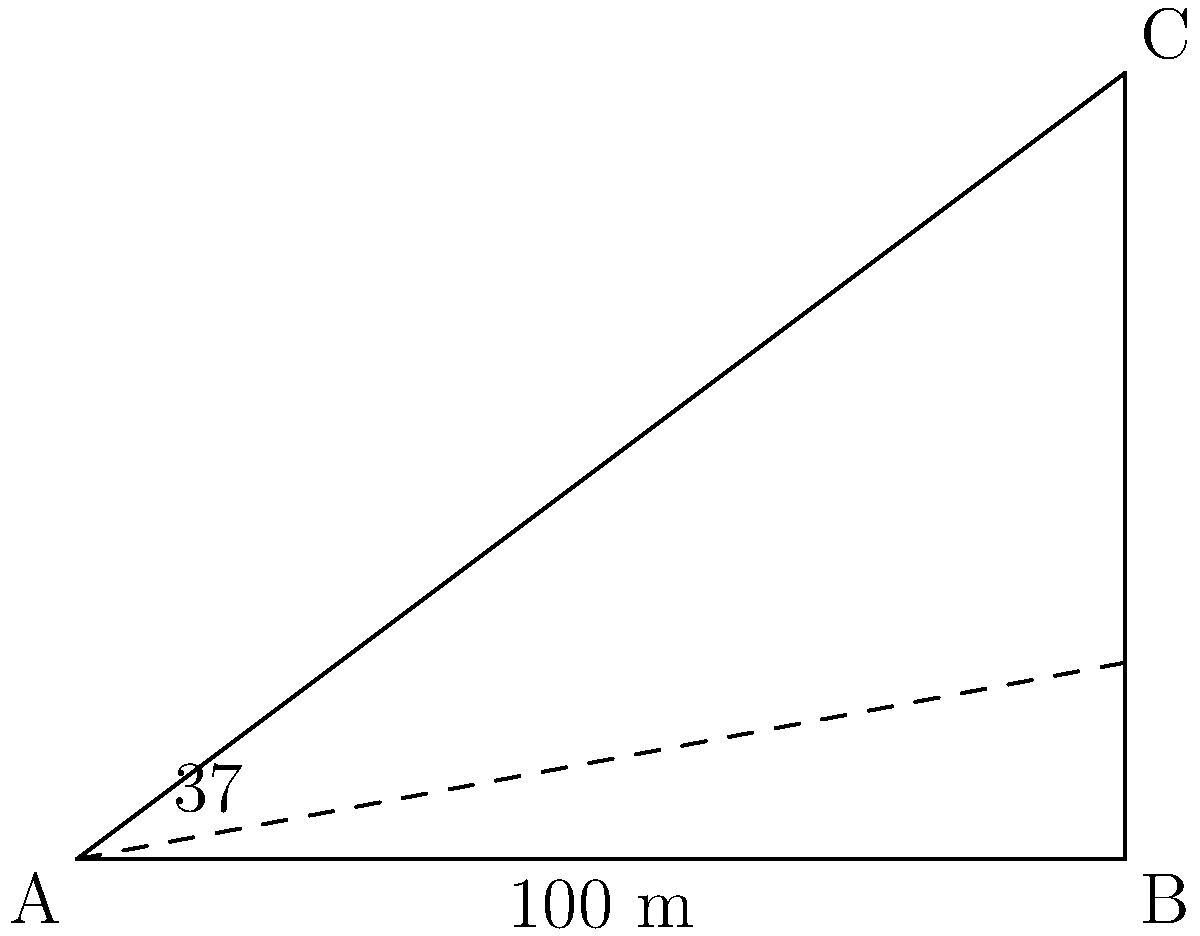From your office window, you observe the construction of a new factory chimney across the street. Using a clinometer, you measure the angle of elevation to the top of the chimney to be 37°. If your office is 100 meters away from the base of the chimney, what is the height of the newly constructed factory chimney? Round your answer to the nearest meter. Let's approach this step-by-step:

1) We can model this situation as a right-angled triangle, where:
   - The base of the triangle is the distance from your office to the chimney (100 m)
   - The height of the triangle is the height of the chimney
   - The angle at the base is the angle of elevation (37°)

2) In a right-angled triangle, we can use the tangent function to find the height:

   $\tan(\theta) = \frac{\text{opposite}}{\text{adjacent}} = \frac{\text{height}}{\text{distance}}$

3) We know the angle (37°) and the distance (100 m), so we can set up the equation:

   $\tan(37°) = \frac{\text{height}}{100}$

4) To find the height, we multiply both sides by 100:

   $\text{height} = 100 \times \tan(37°)$

5) Using a calculator (or a trigonometric table):

   $\text{height} = 100 \times 0.7536 = 75.36$ meters

6) Rounding to the nearest meter:

   $\text{height} \approx 75$ meters
Answer: 75 meters 